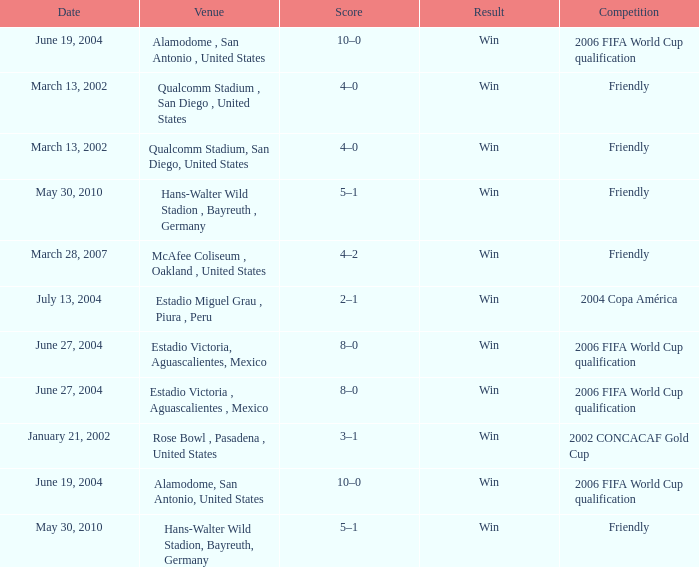When is the alamodome in san antonio, us being used as the venue? June 19, 2004, June 19, 2004. 